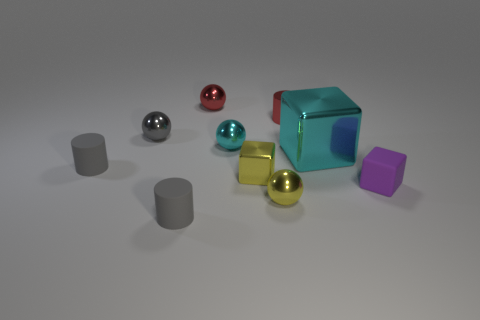Can you describe the lighting in the scene? The lighting in the image appears to be soft and diffused, coming from above and casting gentle shadows beneath the objects, suggesting an evenly lit indoor environment. 